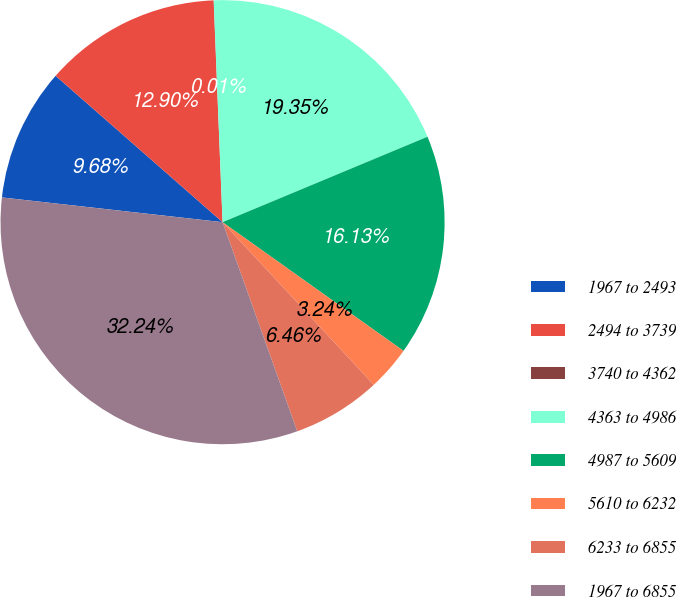<chart> <loc_0><loc_0><loc_500><loc_500><pie_chart><fcel>1967 to 2493<fcel>2494 to 3739<fcel>3740 to 4362<fcel>4363 to 4986<fcel>4987 to 5609<fcel>5610 to 6232<fcel>6233 to 6855<fcel>1967 to 6855<nl><fcel>9.68%<fcel>12.9%<fcel>0.01%<fcel>19.35%<fcel>16.13%<fcel>3.24%<fcel>6.46%<fcel>32.24%<nl></chart> 